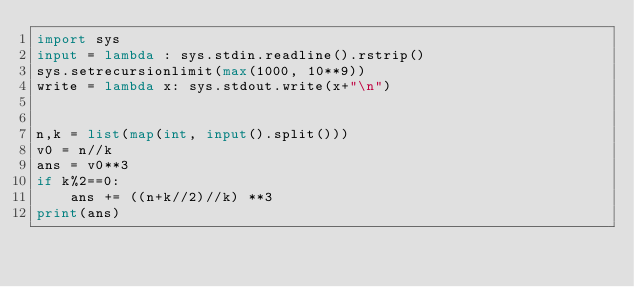<code> <loc_0><loc_0><loc_500><loc_500><_Python_>import sys
input = lambda : sys.stdin.readline().rstrip()
sys.setrecursionlimit(max(1000, 10**9))
write = lambda x: sys.stdout.write(x+"\n")


n,k = list(map(int, input().split()))
v0 = n//k
ans = v0**3
if k%2==0:
    ans += ((n+k//2)//k) **3
print(ans)</code> 